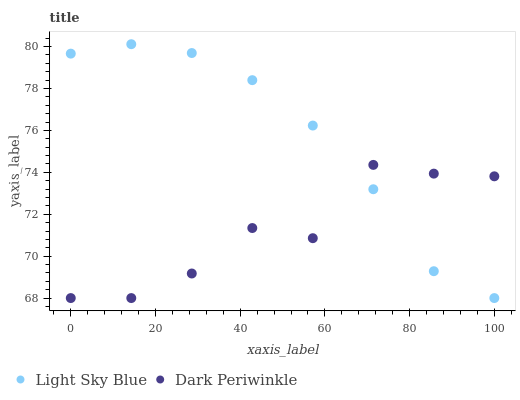Does Dark Periwinkle have the minimum area under the curve?
Answer yes or no. Yes. Does Light Sky Blue have the maximum area under the curve?
Answer yes or no. Yes. Does Dark Periwinkle have the maximum area under the curve?
Answer yes or no. No. Is Light Sky Blue the smoothest?
Answer yes or no. Yes. Is Dark Periwinkle the roughest?
Answer yes or no. Yes. Is Dark Periwinkle the smoothest?
Answer yes or no. No. Does Light Sky Blue have the lowest value?
Answer yes or no. Yes. Does Light Sky Blue have the highest value?
Answer yes or no. Yes. Does Dark Periwinkle have the highest value?
Answer yes or no. No. Does Dark Periwinkle intersect Light Sky Blue?
Answer yes or no. Yes. Is Dark Periwinkle less than Light Sky Blue?
Answer yes or no. No. Is Dark Periwinkle greater than Light Sky Blue?
Answer yes or no. No. 